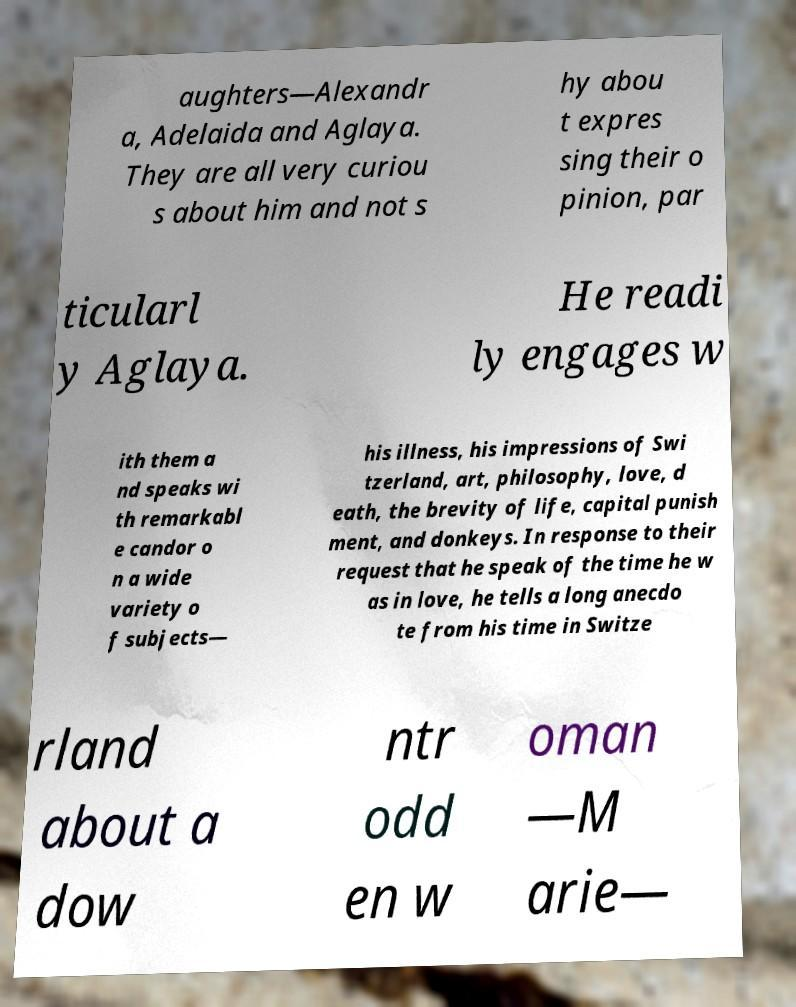Could you assist in decoding the text presented in this image and type it out clearly? aughters—Alexandr a, Adelaida and Aglaya. They are all very curiou s about him and not s hy abou t expres sing their o pinion, par ticularl y Aglaya. He readi ly engages w ith them a nd speaks wi th remarkabl e candor o n a wide variety o f subjects— his illness, his impressions of Swi tzerland, art, philosophy, love, d eath, the brevity of life, capital punish ment, and donkeys. In response to their request that he speak of the time he w as in love, he tells a long anecdo te from his time in Switze rland about a dow ntr odd en w oman —M arie— 